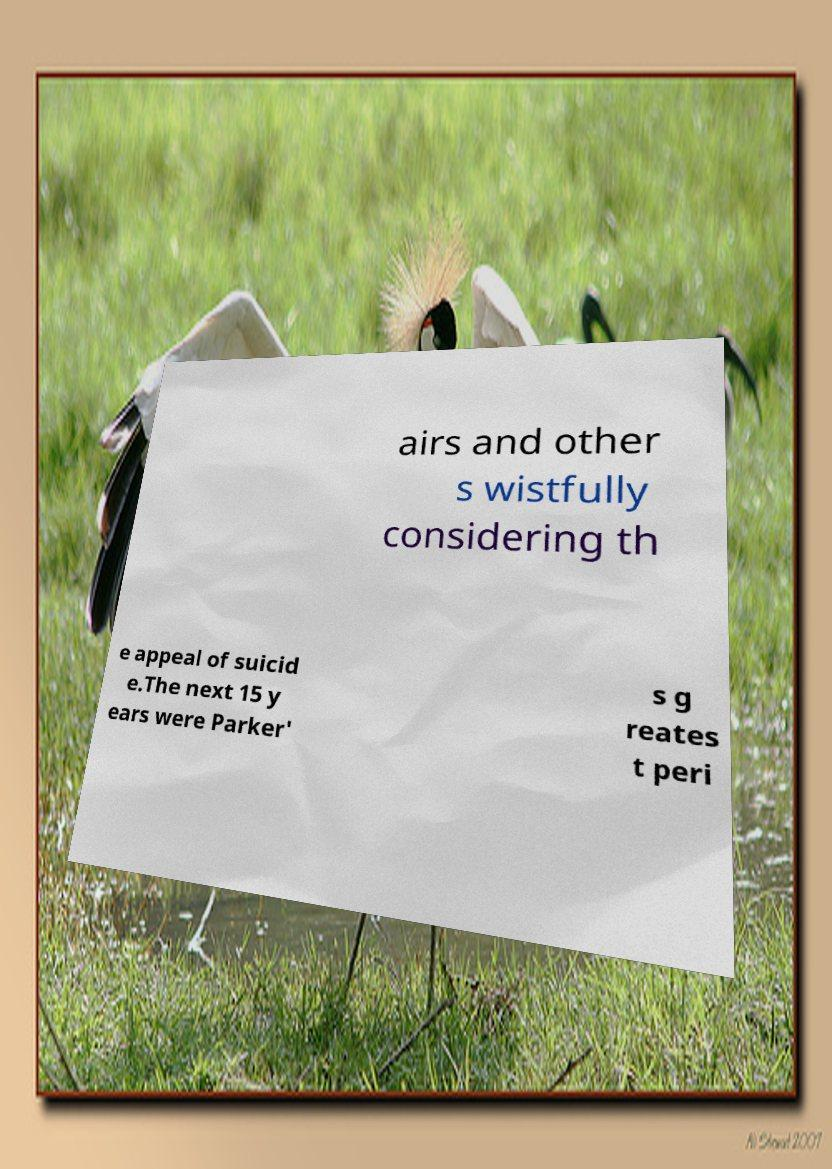Can you accurately transcribe the text from the provided image for me? airs and other s wistfully considering th e appeal of suicid e.The next 15 y ears were Parker' s g reates t peri 